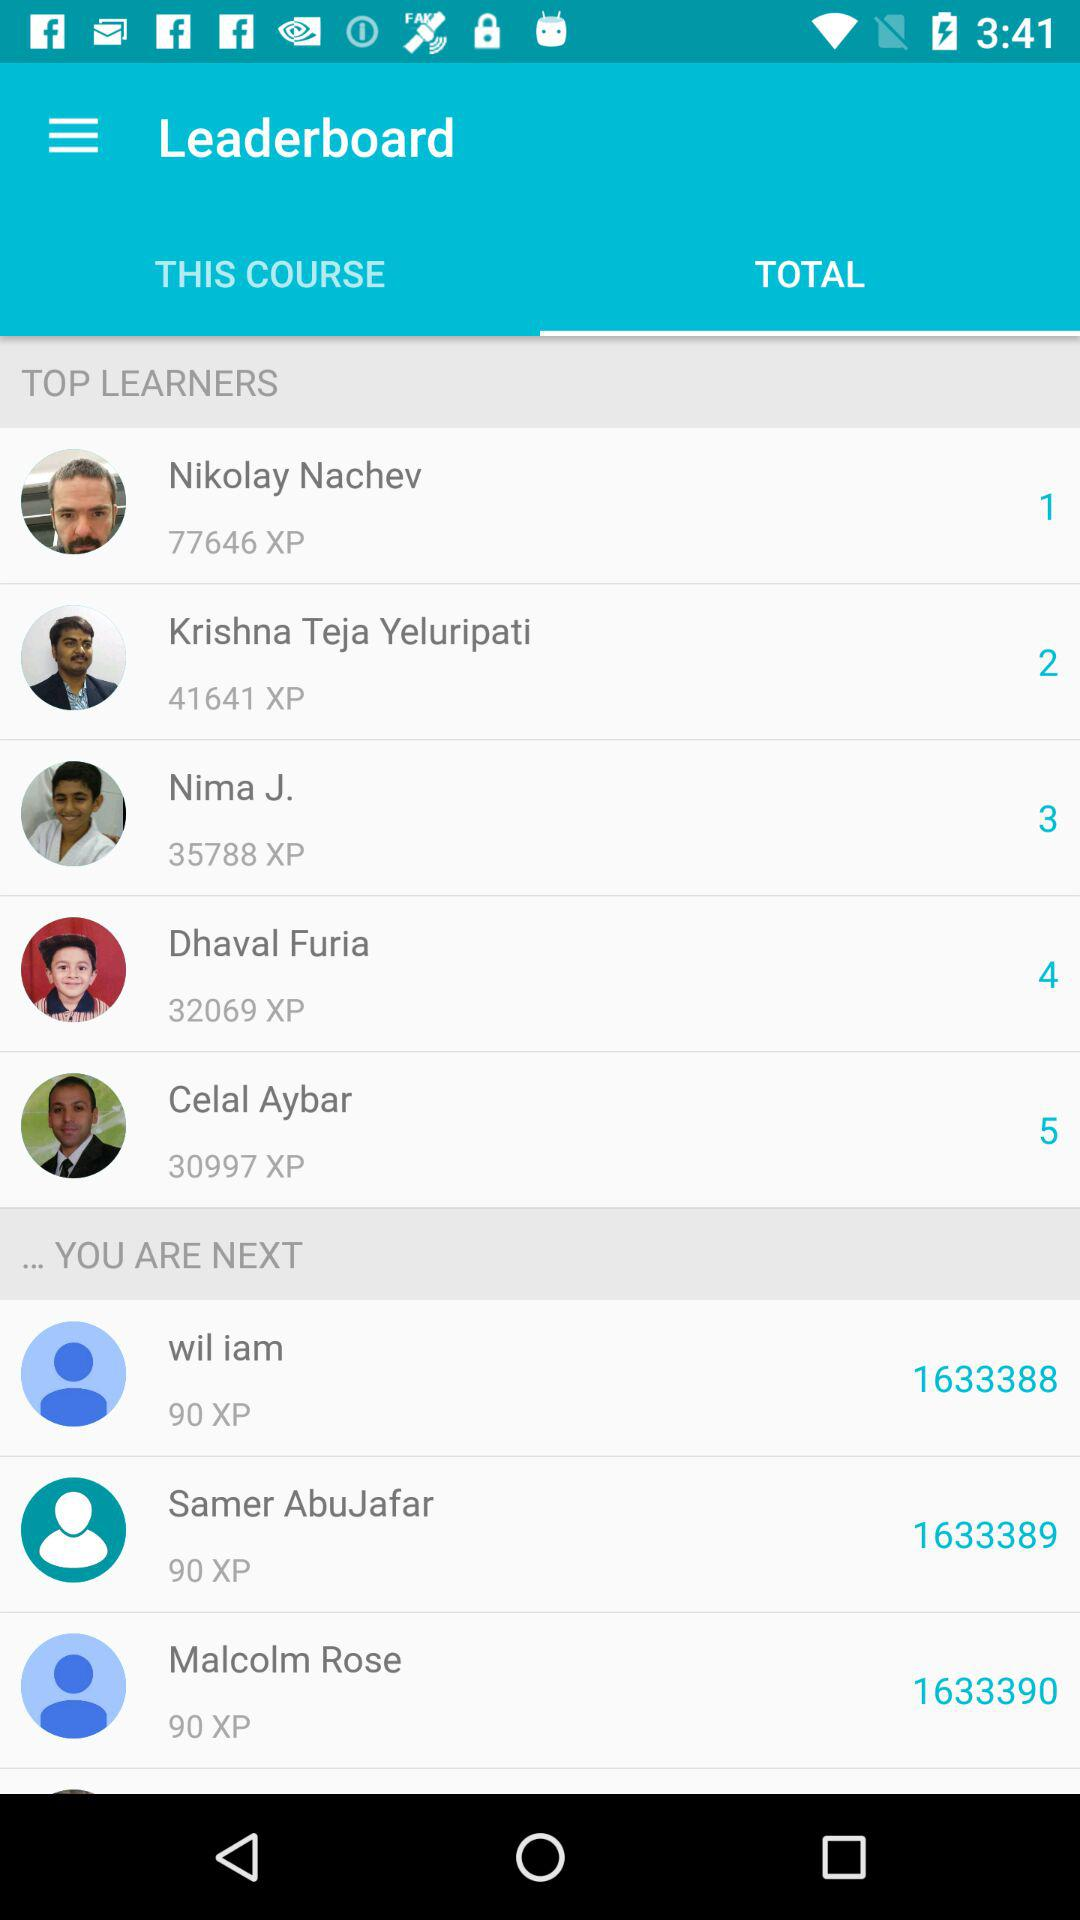Which option is selected in the "Leaderboard"? The selected option is "TOTAL". 